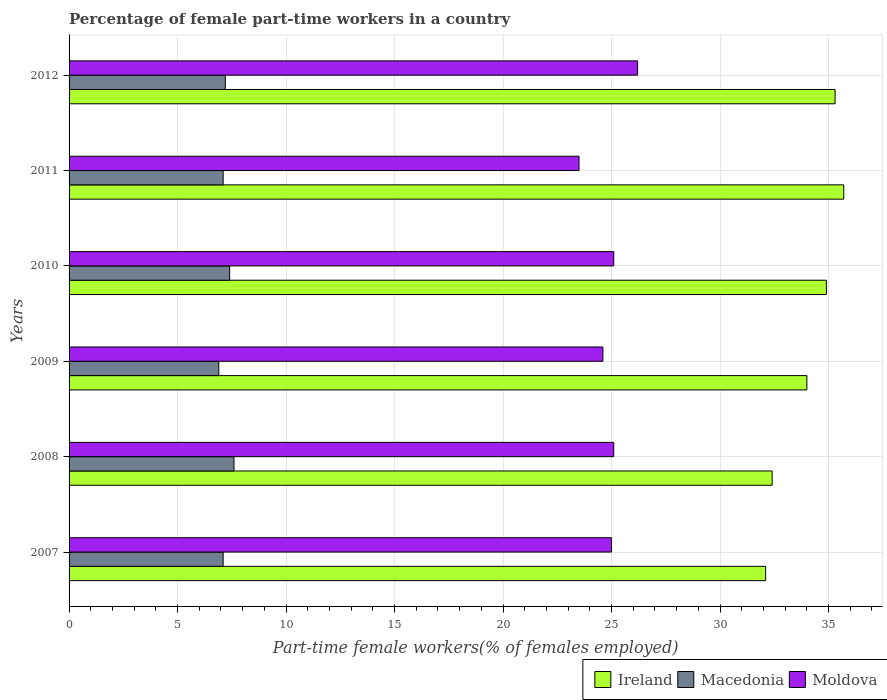How many different coloured bars are there?
Make the answer very short. 3. How many groups of bars are there?
Keep it short and to the point. 6. Are the number of bars per tick equal to the number of legend labels?
Give a very brief answer. Yes. How many bars are there on the 6th tick from the bottom?
Your answer should be very brief. 3. What is the label of the 4th group of bars from the top?
Keep it short and to the point. 2009. What is the percentage of female part-time workers in Moldova in 2009?
Your answer should be compact. 24.6. Across all years, what is the maximum percentage of female part-time workers in Macedonia?
Give a very brief answer. 7.6. Across all years, what is the minimum percentage of female part-time workers in Ireland?
Ensure brevity in your answer.  32.1. In which year was the percentage of female part-time workers in Ireland maximum?
Ensure brevity in your answer.  2011. In which year was the percentage of female part-time workers in Ireland minimum?
Provide a succinct answer. 2007. What is the total percentage of female part-time workers in Ireland in the graph?
Provide a succinct answer. 204.4. What is the difference between the percentage of female part-time workers in Macedonia in 2008 and that in 2010?
Provide a short and direct response. 0.2. What is the difference between the percentage of female part-time workers in Macedonia in 2007 and the percentage of female part-time workers in Moldova in 2012?
Offer a very short reply. -19.1. What is the average percentage of female part-time workers in Moldova per year?
Provide a short and direct response. 24.92. In the year 2007, what is the difference between the percentage of female part-time workers in Macedonia and percentage of female part-time workers in Moldova?
Your answer should be very brief. -17.9. In how many years, is the percentage of female part-time workers in Macedonia greater than 16 %?
Give a very brief answer. 0. What is the ratio of the percentage of female part-time workers in Ireland in 2008 to that in 2012?
Keep it short and to the point. 0.92. Is the percentage of female part-time workers in Macedonia in 2011 less than that in 2012?
Your answer should be very brief. Yes. Is the difference between the percentage of female part-time workers in Macedonia in 2010 and 2011 greater than the difference between the percentage of female part-time workers in Moldova in 2010 and 2011?
Keep it short and to the point. No. What is the difference between the highest and the second highest percentage of female part-time workers in Ireland?
Provide a succinct answer. 0.4. What is the difference between the highest and the lowest percentage of female part-time workers in Moldova?
Provide a short and direct response. 2.7. Is the sum of the percentage of female part-time workers in Macedonia in 2010 and 2012 greater than the maximum percentage of female part-time workers in Moldova across all years?
Keep it short and to the point. No. What does the 1st bar from the top in 2011 represents?
Your answer should be very brief. Moldova. What does the 3rd bar from the bottom in 2007 represents?
Ensure brevity in your answer.  Moldova. Is it the case that in every year, the sum of the percentage of female part-time workers in Macedonia and percentage of female part-time workers in Ireland is greater than the percentage of female part-time workers in Moldova?
Keep it short and to the point. Yes. What is the difference between two consecutive major ticks on the X-axis?
Your answer should be very brief. 5. Are the values on the major ticks of X-axis written in scientific E-notation?
Provide a short and direct response. No. Does the graph contain any zero values?
Make the answer very short. No. Where does the legend appear in the graph?
Ensure brevity in your answer.  Bottom right. What is the title of the graph?
Your response must be concise. Percentage of female part-time workers in a country. Does "Malaysia" appear as one of the legend labels in the graph?
Ensure brevity in your answer.  No. What is the label or title of the X-axis?
Your response must be concise. Part-time female workers(% of females employed). What is the Part-time female workers(% of females employed) of Ireland in 2007?
Offer a terse response. 32.1. What is the Part-time female workers(% of females employed) in Macedonia in 2007?
Your answer should be very brief. 7.1. What is the Part-time female workers(% of females employed) in Moldova in 2007?
Offer a very short reply. 25. What is the Part-time female workers(% of females employed) of Ireland in 2008?
Your answer should be compact. 32.4. What is the Part-time female workers(% of females employed) in Macedonia in 2008?
Provide a short and direct response. 7.6. What is the Part-time female workers(% of females employed) in Moldova in 2008?
Your answer should be very brief. 25.1. What is the Part-time female workers(% of females employed) in Ireland in 2009?
Your answer should be compact. 34. What is the Part-time female workers(% of females employed) of Macedonia in 2009?
Your answer should be compact. 6.9. What is the Part-time female workers(% of females employed) of Moldova in 2009?
Your response must be concise. 24.6. What is the Part-time female workers(% of females employed) of Ireland in 2010?
Your answer should be compact. 34.9. What is the Part-time female workers(% of females employed) of Macedonia in 2010?
Offer a very short reply. 7.4. What is the Part-time female workers(% of females employed) of Moldova in 2010?
Your response must be concise. 25.1. What is the Part-time female workers(% of females employed) in Ireland in 2011?
Give a very brief answer. 35.7. What is the Part-time female workers(% of females employed) in Macedonia in 2011?
Keep it short and to the point. 7.1. What is the Part-time female workers(% of females employed) in Ireland in 2012?
Offer a very short reply. 35.3. What is the Part-time female workers(% of females employed) of Macedonia in 2012?
Your answer should be compact. 7.2. What is the Part-time female workers(% of females employed) of Moldova in 2012?
Your response must be concise. 26.2. Across all years, what is the maximum Part-time female workers(% of females employed) in Ireland?
Your answer should be very brief. 35.7. Across all years, what is the maximum Part-time female workers(% of females employed) of Macedonia?
Ensure brevity in your answer.  7.6. Across all years, what is the maximum Part-time female workers(% of females employed) of Moldova?
Offer a terse response. 26.2. Across all years, what is the minimum Part-time female workers(% of females employed) of Ireland?
Provide a short and direct response. 32.1. Across all years, what is the minimum Part-time female workers(% of females employed) of Macedonia?
Keep it short and to the point. 6.9. What is the total Part-time female workers(% of females employed) in Ireland in the graph?
Your answer should be very brief. 204.4. What is the total Part-time female workers(% of females employed) in Macedonia in the graph?
Give a very brief answer. 43.3. What is the total Part-time female workers(% of females employed) in Moldova in the graph?
Provide a short and direct response. 149.5. What is the difference between the Part-time female workers(% of females employed) in Ireland in 2007 and that in 2008?
Ensure brevity in your answer.  -0.3. What is the difference between the Part-time female workers(% of females employed) of Moldova in 2007 and that in 2010?
Make the answer very short. -0.1. What is the difference between the Part-time female workers(% of females employed) of Macedonia in 2007 and that in 2011?
Provide a short and direct response. 0. What is the difference between the Part-time female workers(% of females employed) of Moldova in 2007 and that in 2011?
Provide a short and direct response. 1.5. What is the difference between the Part-time female workers(% of females employed) of Ireland in 2007 and that in 2012?
Your answer should be compact. -3.2. What is the difference between the Part-time female workers(% of females employed) of Ireland in 2008 and that in 2009?
Ensure brevity in your answer.  -1.6. What is the difference between the Part-time female workers(% of females employed) in Macedonia in 2008 and that in 2010?
Your answer should be compact. 0.2. What is the difference between the Part-time female workers(% of females employed) in Ireland in 2008 and that in 2011?
Make the answer very short. -3.3. What is the difference between the Part-time female workers(% of females employed) in Ireland in 2008 and that in 2012?
Your response must be concise. -2.9. What is the difference between the Part-time female workers(% of females employed) of Moldova in 2008 and that in 2012?
Offer a very short reply. -1.1. What is the difference between the Part-time female workers(% of females employed) of Ireland in 2009 and that in 2010?
Provide a succinct answer. -0.9. What is the difference between the Part-time female workers(% of females employed) in Ireland in 2009 and that in 2012?
Your response must be concise. -1.3. What is the difference between the Part-time female workers(% of females employed) in Macedonia in 2009 and that in 2012?
Your answer should be very brief. -0.3. What is the difference between the Part-time female workers(% of females employed) in Moldova in 2009 and that in 2012?
Give a very brief answer. -1.6. What is the difference between the Part-time female workers(% of females employed) of Macedonia in 2010 and that in 2011?
Offer a very short reply. 0.3. What is the difference between the Part-time female workers(% of females employed) in Macedonia in 2010 and that in 2012?
Give a very brief answer. 0.2. What is the difference between the Part-time female workers(% of females employed) of Ireland in 2011 and that in 2012?
Make the answer very short. 0.4. What is the difference between the Part-time female workers(% of females employed) in Moldova in 2011 and that in 2012?
Your answer should be compact. -2.7. What is the difference between the Part-time female workers(% of females employed) in Ireland in 2007 and the Part-time female workers(% of females employed) in Moldova in 2008?
Your answer should be compact. 7. What is the difference between the Part-time female workers(% of females employed) in Macedonia in 2007 and the Part-time female workers(% of females employed) in Moldova in 2008?
Provide a short and direct response. -18. What is the difference between the Part-time female workers(% of females employed) of Ireland in 2007 and the Part-time female workers(% of females employed) of Macedonia in 2009?
Give a very brief answer. 25.2. What is the difference between the Part-time female workers(% of females employed) of Ireland in 2007 and the Part-time female workers(% of females employed) of Moldova in 2009?
Keep it short and to the point. 7.5. What is the difference between the Part-time female workers(% of females employed) in Macedonia in 2007 and the Part-time female workers(% of females employed) in Moldova in 2009?
Offer a very short reply. -17.5. What is the difference between the Part-time female workers(% of females employed) in Ireland in 2007 and the Part-time female workers(% of females employed) in Macedonia in 2010?
Ensure brevity in your answer.  24.7. What is the difference between the Part-time female workers(% of females employed) of Ireland in 2007 and the Part-time female workers(% of females employed) of Moldova in 2010?
Provide a short and direct response. 7. What is the difference between the Part-time female workers(% of females employed) of Macedonia in 2007 and the Part-time female workers(% of females employed) of Moldova in 2010?
Provide a succinct answer. -18. What is the difference between the Part-time female workers(% of females employed) of Ireland in 2007 and the Part-time female workers(% of females employed) of Macedonia in 2011?
Provide a short and direct response. 25. What is the difference between the Part-time female workers(% of females employed) of Macedonia in 2007 and the Part-time female workers(% of females employed) of Moldova in 2011?
Offer a very short reply. -16.4. What is the difference between the Part-time female workers(% of females employed) of Ireland in 2007 and the Part-time female workers(% of females employed) of Macedonia in 2012?
Keep it short and to the point. 24.9. What is the difference between the Part-time female workers(% of females employed) in Ireland in 2007 and the Part-time female workers(% of females employed) in Moldova in 2012?
Offer a terse response. 5.9. What is the difference between the Part-time female workers(% of females employed) in Macedonia in 2007 and the Part-time female workers(% of females employed) in Moldova in 2012?
Ensure brevity in your answer.  -19.1. What is the difference between the Part-time female workers(% of females employed) in Macedonia in 2008 and the Part-time female workers(% of females employed) in Moldova in 2009?
Offer a very short reply. -17. What is the difference between the Part-time female workers(% of females employed) of Macedonia in 2008 and the Part-time female workers(% of females employed) of Moldova in 2010?
Provide a succinct answer. -17.5. What is the difference between the Part-time female workers(% of females employed) in Ireland in 2008 and the Part-time female workers(% of females employed) in Macedonia in 2011?
Provide a succinct answer. 25.3. What is the difference between the Part-time female workers(% of females employed) in Macedonia in 2008 and the Part-time female workers(% of females employed) in Moldova in 2011?
Provide a succinct answer. -15.9. What is the difference between the Part-time female workers(% of females employed) in Ireland in 2008 and the Part-time female workers(% of females employed) in Macedonia in 2012?
Provide a short and direct response. 25.2. What is the difference between the Part-time female workers(% of females employed) of Macedonia in 2008 and the Part-time female workers(% of females employed) of Moldova in 2012?
Offer a terse response. -18.6. What is the difference between the Part-time female workers(% of females employed) in Ireland in 2009 and the Part-time female workers(% of females employed) in Macedonia in 2010?
Keep it short and to the point. 26.6. What is the difference between the Part-time female workers(% of females employed) in Macedonia in 2009 and the Part-time female workers(% of females employed) in Moldova in 2010?
Offer a very short reply. -18.2. What is the difference between the Part-time female workers(% of females employed) in Ireland in 2009 and the Part-time female workers(% of females employed) in Macedonia in 2011?
Offer a terse response. 26.9. What is the difference between the Part-time female workers(% of females employed) of Macedonia in 2009 and the Part-time female workers(% of females employed) of Moldova in 2011?
Make the answer very short. -16.6. What is the difference between the Part-time female workers(% of females employed) of Ireland in 2009 and the Part-time female workers(% of females employed) of Macedonia in 2012?
Offer a very short reply. 26.8. What is the difference between the Part-time female workers(% of females employed) of Ireland in 2009 and the Part-time female workers(% of females employed) of Moldova in 2012?
Make the answer very short. 7.8. What is the difference between the Part-time female workers(% of females employed) in Macedonia in 2009 and the Part-time female workers(% of females employed) in Moldova in 2012?
Your answer should be compact. -19.3. What is the difference between the Part-time female workers(% of females employed) in Ireland in 2010 and the Part-time female workers(% of females employed) in Macedonia in 2011?
Offer a very short reply. 27.8. What is the difference between the Part-time female workers(% of females employed) of Ireland in 2010 and the Part-time female workers(% of females employed) of Moldova in 2011?
Keep it short and to the point. 11.4. What is the difference between the Part-time female workers(% of females employed) in Macedonia in 2010 and the Part-time female workers(% of females employed) in Moldova in 2011?
Your response must be concise. -16.1. What is the difference between the Part-time female workers(% of females employed) of Ireland in 2010 and the Part-time female workers(% of females employed) of Macedonia in 2012?
Make the answer very short. 27.7. What is the difference between the Part-time female workers(% of females employed) in Macedonia in 2010 and the Part-time female workers(% of females employed) in Moldova in 2012?
Your response must be concise. -18.8. What is the difference between the Part-time female workers(% of females employed) of Macedonia in 2011 and the Part-time female workers(% of females employed) of Moldova in 2012?
Offer a very short reply. -19.1. What is the average Part-time female workers(% of females employed) of Ireland per year?
Offer a very short reply. 34.07. What is the average Part-time female workers(% of females employed) in Macedonia per year?
Make the answer very short. 7.22. What is the average Part-time female workers(% of females employed) in Moldova per year?
Ensure brevity in your answer.  24.92. In the year 2007, what is the difference between the Part-time female workers(% of females employed) in Ireland and Part-time female workers(% of females employed) in Macedonia?
Your answer should be compact. 25. In the year 2007, what is the difference between the Part-time female workers(% of females employed) of Macedonia and Part-time female workers(% of females employed) of Moldova?
Your answer should be compact. -17.9. In the year 2008, what is the difference between the Part-time female workers(% of females employed) in Ireland and Part-time female workers(% of females employed) in Macedonia?
Keep it short and to the point. 24.8. In the year 2008, what is the difference between the Part-time female workers(% of females employed) of Macedonia and Part-time female workers(% of females employed) of Moldova?
Give a very brief answer. -17.5. In the year 2009, what is the difference between the Part-time female workers(% of females employed) in Ireland and Part-time female workers(% of females employed) in Macedonia?
Provide a short and direct response. 27.1. In the year 2009, what is the difference between the Part-time female workers(% of females employed) of Macedonia and Part-time female workers(% of females employed) of Moldova?
Your response must be concise. -17.7. In the year 2010, what is the difference between the Part-time female workers(% of females employed) in Ireland and Part-time female workers(% of females employed) in Macedonia?
Provide a short and direct response. 27.5. In the year 2010, what is the difference between the Part-time female workers(% of females employed) in Ireland and Part-time female workers(% of females employed) in Moldova?
Ensure brevity in your answer.  9.8. In the year 2010, what is the difference between the Part-time female workers(% of females employed) of Macedonia and Part-time female workers(% of females employed) of Moldova?
Provide a succinct answer. -17.7. In the year 2011, what is the difference between the Part-time female workers(% of females employed) in Ireland and Part-time female workers(% of females employed) in Macedonia?
Your answer should be compact. 28.6. In the year 2011, what is the difference between the Part-time female workers(% of females employed) in Ireland and Part-time female workers(% of females employed) in Moldova?
Your answer should be compact. 12.2. In the year 2011, what is the difference between the Part-time female workers(% of females employed) in Macedonia and Part-time female workers(% of females employed) in Moldova?
Make the answer very short. -16.4. In the year 2012, what is the difference between the Part-time female workers(% of females employed) in Ireland and Part-time female workers(% of females employed) in Macedonia?
Your answer should be compact. 28.1. In the year 2012, what is the difference between the Part-time female workers(% of females employed) of Ireland and Part-time female workers(% of females employed) of Moldova?
Your answer should be very brief. 9.1. What is the ratio of the Part-time female workers(% of females employed) in Macedonia in 2007 to that in 2008?
Provide a succinct answer. 0.93. What is the ratio of the Part-time female workers(% of females employed) of Moldova in 2007 to that in 2008?
Provide a short and direct response. 1. What is the ratio of the Part-time female workers(% of females employed) in Ireland in 2007 to that in 2009?
Your answer should be very brief. 0.94. What is the ratio of the Part-time female workers(% of females employed) of Macedonia in 2007 to that in 2009?
Keep it short and to the point. 1.03. What is the ratio of the Part-time female workers(% of females employed) in Moldova in 2007 to that in 2009?
Make the answer very short. 1.02. What is the ratio of the Part-time female workers(% of females employed) in Ireland in 2007 to that in 2010?
Offer a very short reply. 0.92. What is the ratio of the Part-time female workers(% of females employed) of Macedonia in 2007 to that in 2010?
Make the answer very short. 0.96. What is the ratio of the Part-time female workers(% of females employed) of Ireland in 2007 to that in 2011?
Offer a very short reply. 0.9. What is the ratio of the Part-time female workers(% of females employed) of Moldova in 2007 to that in 2011?
Your answer should be compact. 1.06. What is the ratio of the Part-time female workers(% of females employed) of Ireland in 2007 to that in 2012?
Your answer should be very brief. 0.91. What is the ratio of the Part-time female workers(% of females employed) of Macedonia in 2007 to that in 2012?
Give a very brief answer. 0.99. What is the ratio of the Part-time female workers(% of females employed) in Moldova in 2007 to that in 2012?
Your answer should be compact. 0.95. What is the ratio of the Part-time female workers(% of females employed) of Ireland in 2008 to that in 2009?
Your answer should be compact. 0.95. What is the ratio of the Part-time female workers(% of females employed) of Macedonia in 2008 to that in 2009?
Make the answer very short. 1.1. What is the ratio of the Part-time female workers(% of females employed) of Moldova in 2008 to that in 2009?
Your response must be concise. 1.02. What is the ratio of the Part-time female workers(% of females employed) of Ireland in 2008 to that in 2010?
Offer a terse response. 0.93. What is the ratio of the Part-time female workers(% of females employed) in Moldova in 2008 to that in 2010?
Make the answer very short. 1. What is the ratio of the Part-time female workers(% of females employed) of Ireland in 2008 to that in 2011?
Your response must be concise. 0.91. What is the ratio of the Part-time female workers(% of females employed) in Macedonia in 2008 to that in 2011?
Your answer should be compact. 1.07. What is the ratio of the Part-time female workers(% of females employed) in Moldova in 2008 to that in 2011?
Offer a terse response. 1.07. What is the ratio of the Part-time female workers(% of females employed) of Ireland in 2008 to that in 2012?
Make the answer very short. 0.92. What is the ratio of the Part-time female workers(% of females employed) of Macedonia in 2008 to that in 2012?
Provide a succinct answer. 1.06. What is the ratio of the Part-time female workers(% of females employed) of Moldova in 2008 to that in 2012?
Your answer should be very brief. 0.96. What is the ratio of the Part-time female workers(% of females employed) of Ireland in 2009 to that in 2010?
Ensure brevity in your answer.  0.97. What is the ratio of the Part-time female workers(% of females employed) of Macedonia in 2009 to that in 2010?
Provide a short and direct response. 0.93. What is the ratio of the Part-time female workers(% of females employed) in Moldova in 2009 to that in 2010?
Make the answer very short. 0.98. What is the ratio of the Part-time female workers(% of females employed) of Ireland in 2009 to that in 2011?
Your answer should be compact. 0.95. What is the ratio of the Part-time female workers(% of females employed) in Macedonia in 2009 to that in 2011?
Your response must be concise. 0.97. What is the ratio of the Part-time female workers(% of females employed) of Moldova in 2009 to that in 2011?
Provide a succinct answer. 1.05. What is the ratio of the Part-time female workers(% of females employed) of Ireland in 2009 to that in 2012?
Offer a very short reply. 0.96. What is the ratio of the Part-time female workers(% of females employed) of Macedonia in 2009 to that in 2012?
Ensure brevity in your answer.  0.96. What is the ratio of the Part-time female workers(% of females employed) of Moldova in 2009 to that in 2012?
Ensure brevity in your answer.  0.94. What is the ratio of the Part-time female workers(% of females employed) in Ireland in 2010 to that in 2011?
Keep it short and to the point. 0.98. What is the ratio of the Part-time female workers(% of females employed) of Macedonia in 2010 to that in 2011?
Provide a short and direct response. 1.04. What is the ratio of the Part-time female workers(% of females employed) of Moldova in 2010 to that in 2011?
Make the answer very short. 1.07. What is the ratio of the Part-time female workers(% of females employed) of Ireland in 2010 to that in 2012?
Provide a succinct answer. 0.99. What is the ratio of the Part-time female workers(% of females employed) of Macedonia in 2010 to that in 2012?
Provide a short and direct response. 1.03. What is the ratio of the Part-time female workers(% of females employed) of Moldova in 2010 to that in 2012?
Provide a succinct answer. 0.96. What is the ratio of the Part-time female workers(% of females employed) of Ireland in 2011 to that in 2012?
Your response must be concise. 1.01. What is the ratio of the Part-time female workers(% of females employed) in Macedonia in 2011 to that in 2012?
Provide a short and direct response. 0.99. What is the ratio of the Part-time female workers(% of females employed) in Moldova in 2011 to that in 2012?
Your answer should be compact. 0.9. What is the difference between the highest and the second highest Part-time female workers(% of females employed) in Ireland?
Ensure brevity in your answer.  0.4. What is the difference between the highest and the lowest Part-time female workers(% of females employed) in Ireland?
Keep it short and to the point. 3.6. What is the difference between the highest and the lowest Part-time female workers(% of females employed) of Moldova?
Offer a terse response. 2.7. 